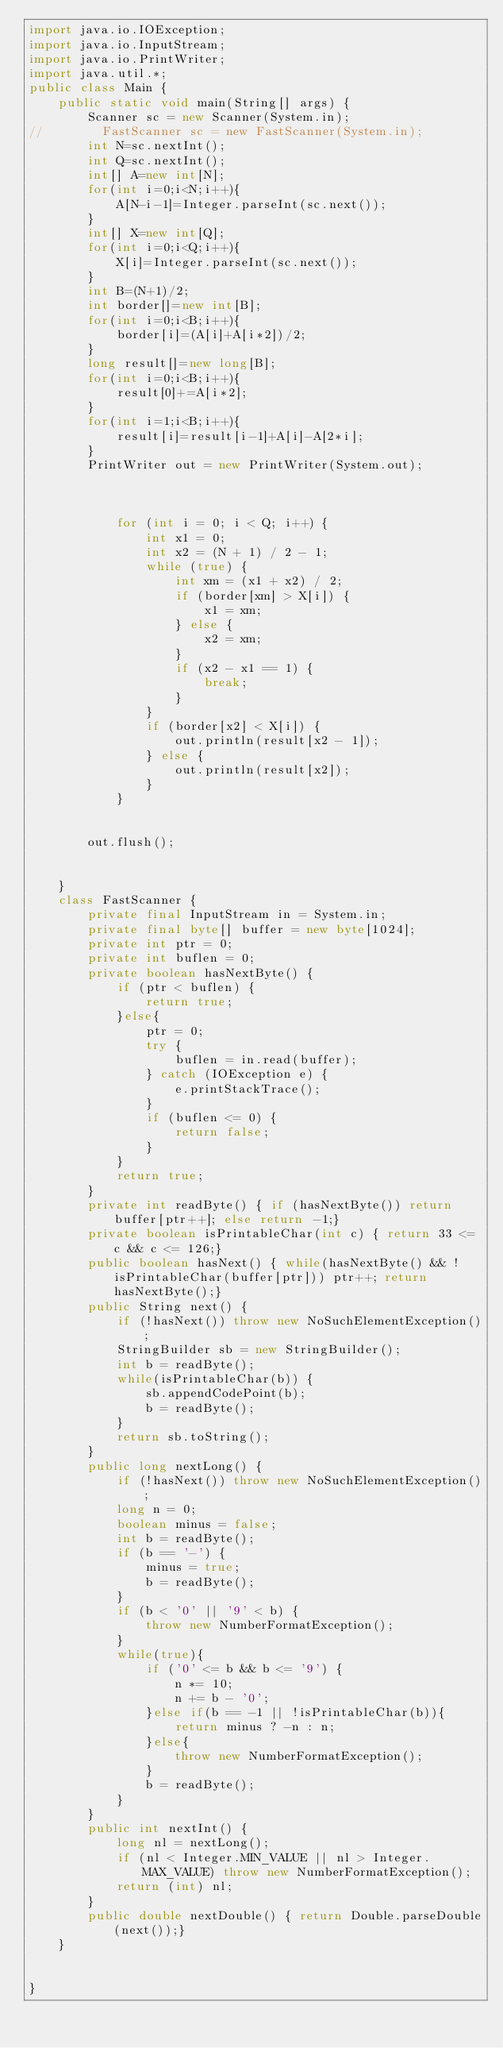<code> <loc_0><loc_0><loc_500><loc_500><_Java_>import java.io.IOException;
import java.io.InputStream;
import java.io.PrintWriter;
import java.util.*;
public class Main {
    public static void main(String[] args) {
        Scanner sc = new Scanner(System.in);
//        FastScanner sc = new FastScanner(System.in);
        int N=sc.nextInt();
        int Q=sc.nextInt();
        int[] A=new int[N];
        for(int i=0;i<N;i++){
            A[N-i-1]=Integer.parseInt(sc.next());
        }
        int[] X=new int[Q];
        for(int i=0;i<Q;i++){
            X[i]=Integer.parseInt(sc.next());
        }
        int B=(N+1)/2;
        int border[]=new int[B];
        for(int i=0;i<B;i++){
            border[i]=(A[i]+A[i*2])/2;
        }
        long result[]=new long[B];
        for(int i=0;i<B;i++){
            result[0]+=A[i*2];
        }
        for(int i=1;i<B;i++){
            result[i]=result[i-1]+A[i]-A[2*i];
        }
        PrintWriter out = new PrintWriter(System.out);



            for (int i = 0; i < Q; i++) {
                int x1 = 0;
                int x2 = (N + 1) / 2 - 1;
                while (true) {
                    int xm = (x1 + x2) / 2;
                    if (border[xm] > X[i]) {
                        x1 = xm;
                    } else {
                        x2 = xm;
                    }
                    if (x2 - x1 == 1) {
                        break;
                    }
                }
                if (border[x2] < X[i]) {
                    out.println(result[x2 - 1]);
                } else {
                    out.println(result[x2]);
                }
            }


        out.flush();


    }
    class FastScanner {
        private final InputStream in = System.in;
        private final byte[] buffer = new byte[1024];
        private int ptr = 0;
        private int buflen = 0;
        private boolean hasNextByte() {
            if (ptr < buflen) {
                return true;
            }else{
                ptr = 0;
                try {
                    buflen = in.read(buffer);
                } catch (IOException e) {
                    e.printStackTrace();
                }
                if (buflen <= 0) {
                    return false;
                }
            }
            return true;
        }
        private int readByte() { if (hasNextByte()) return buffer[ptr++]; else return -1;}
        private boolean isPrintableChar(int c) { return 33 <= c && c <= 126;}
        public boolean hasNext() { while(hasNextByte() && !isPrintableChar(buffer[ptr])) ptr++; return hasNextByte();}
        public String next() {
            if (!hasNext()) throw new NoSuchElementException();
            StringBuilder sb = new StringBuilder();
            int b = readByte();
            while(isPrintableChar(b)) {
                sb.appendCodePoint(b);
                b = readByte();
            }
            return sb.toString();
        }
        public long nextLong() {
            if (!hasNext()) throw new NoSuchElementException();
            long n = 0;
            boolean minus = false;
            int b = readByte();
            if (b == '-') {
                minus = true;
                b = readByte();
            }
            if (b < '0' || '9' < b) {
                throw new NumberFormatException();
            }
            while(true){
                if ('0' <= b && b <= '9') {
                    n *= 10;
                    n += b - '0';
                }else if(b == -1 || !isPrintableChar(b)){
                    return minus ? -n : n;
                }else{
                    throw new NumberFormatException();
                }
                b = readByte();
            }
        }
        public int nextInt() {
            long nl = nextLong();
            if (nl < Integer.MIN_VALUE || nl > Integer.MAX_VALUE) throw new NumberFormatException();
            return (int) nl;
        }
        public double nextDouble() { return Double.parseDouble(next());}
    }


}</code> 